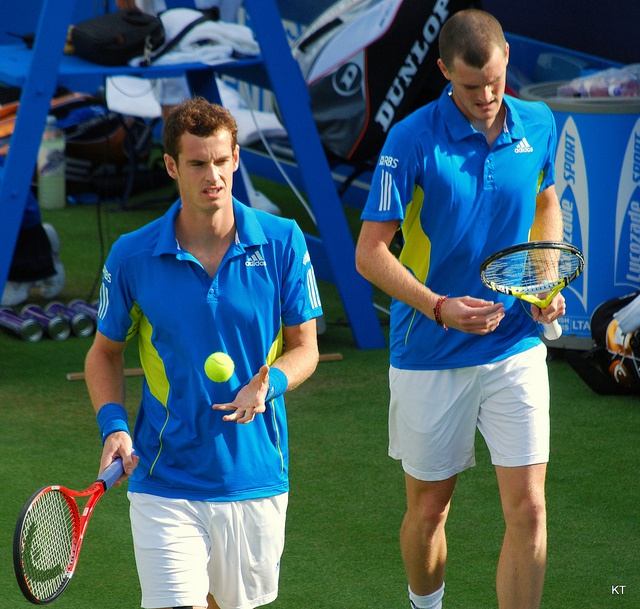Describe the objects in this image and their specific colors. I can see people in darkblue, blue, ivory, and lightblue tones, people in darkblue, darkgray, blue, and olive tones, tennis racket in darkblue, black, darkgreen, gray, and darkgray tones, tennis racket in darkblue, darkgray, black, gray, and khaki tones, and backpack in darkblue, black, darkgray, and gray tones in this image. 